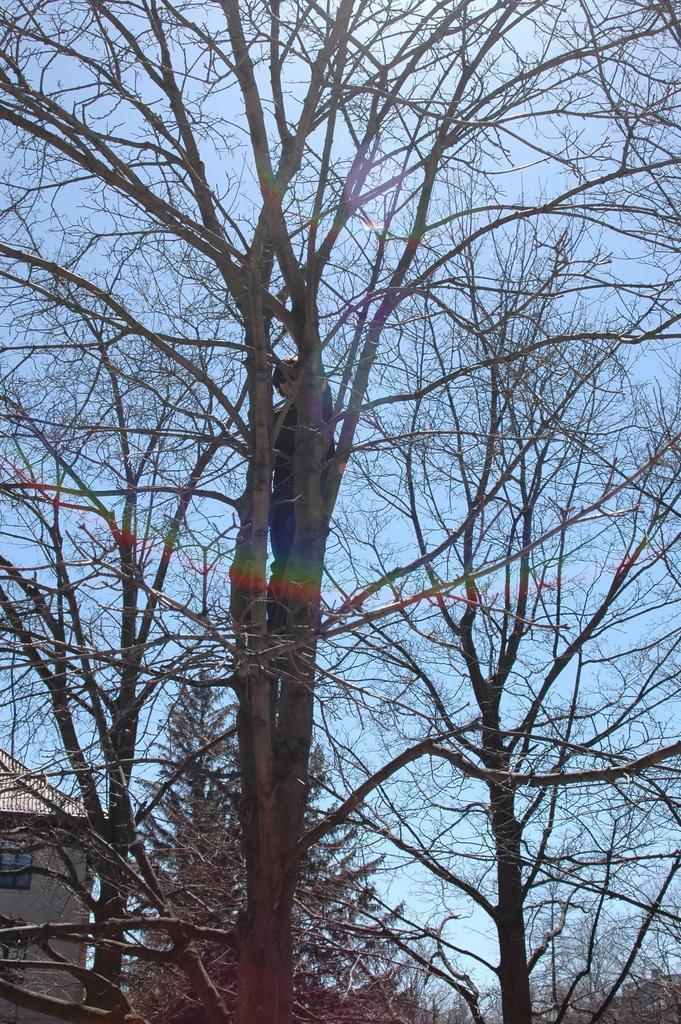How would you summarize this image in a sentence or two? In this image I can see few trees , on top of trees I can see a person , in the bottom left there is a house visible, back side of tree I can see the sky. 